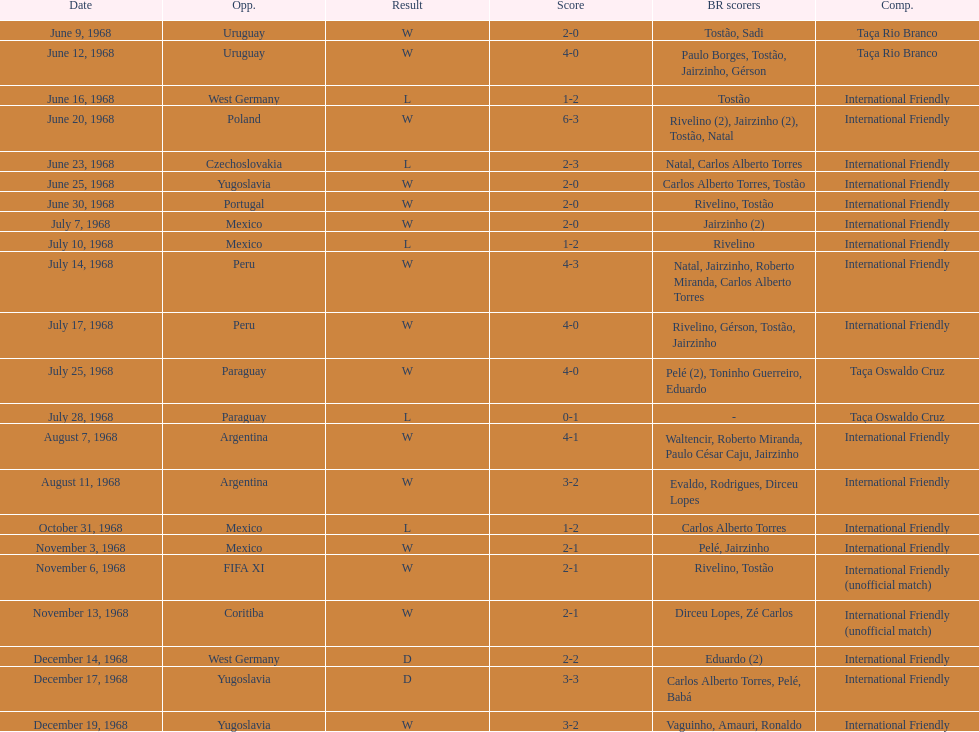Total number of wins 15. 